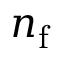Convert formula to latex. <formula><loc_0><loc_0><loc_500><loc_500>n _ { f }</formula> 